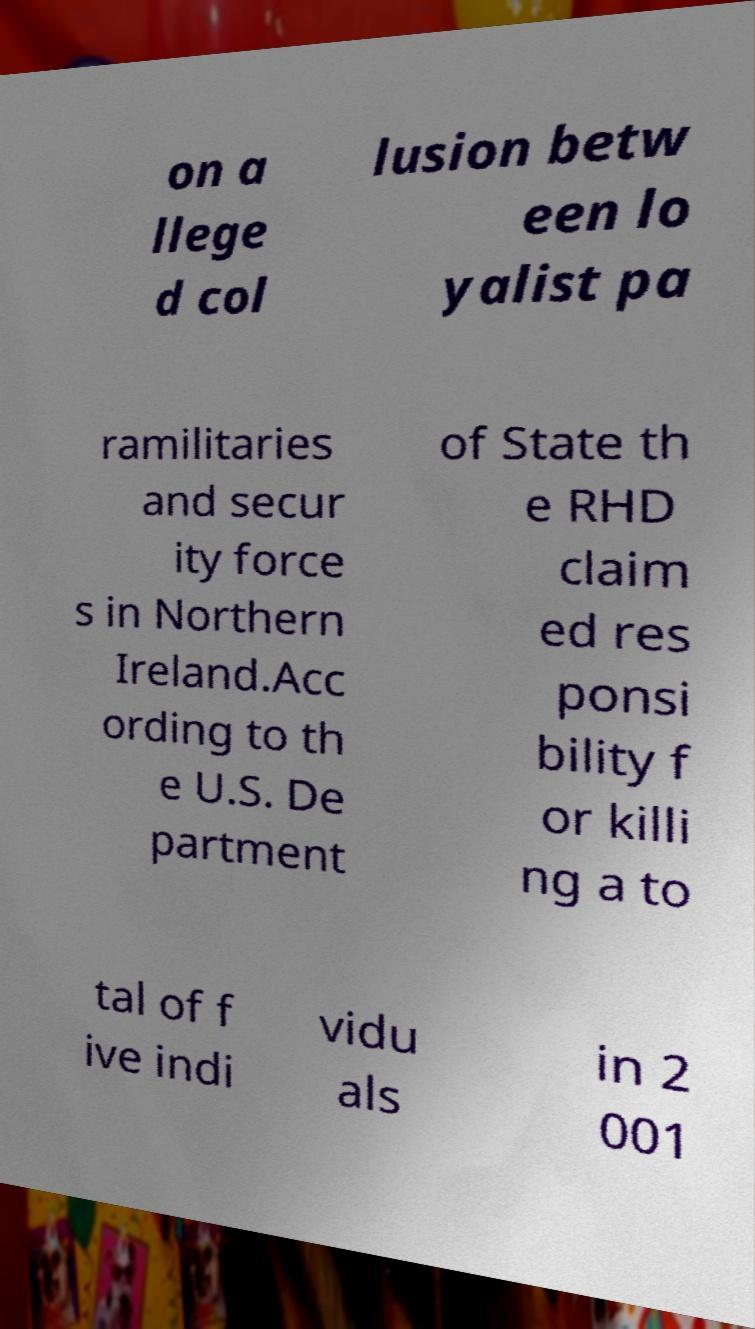Can you accurately transcribe the text from the provided image for me? on a llege d col lusion betw een lo yalist pa ramilitaries and secur ity force s in Northern Ireland.Acc ording to th e U.S. De partment of State th e RHD claim ed res ponsi bility f or killi ng a to tal of f ive indi vidu als in 2 001 